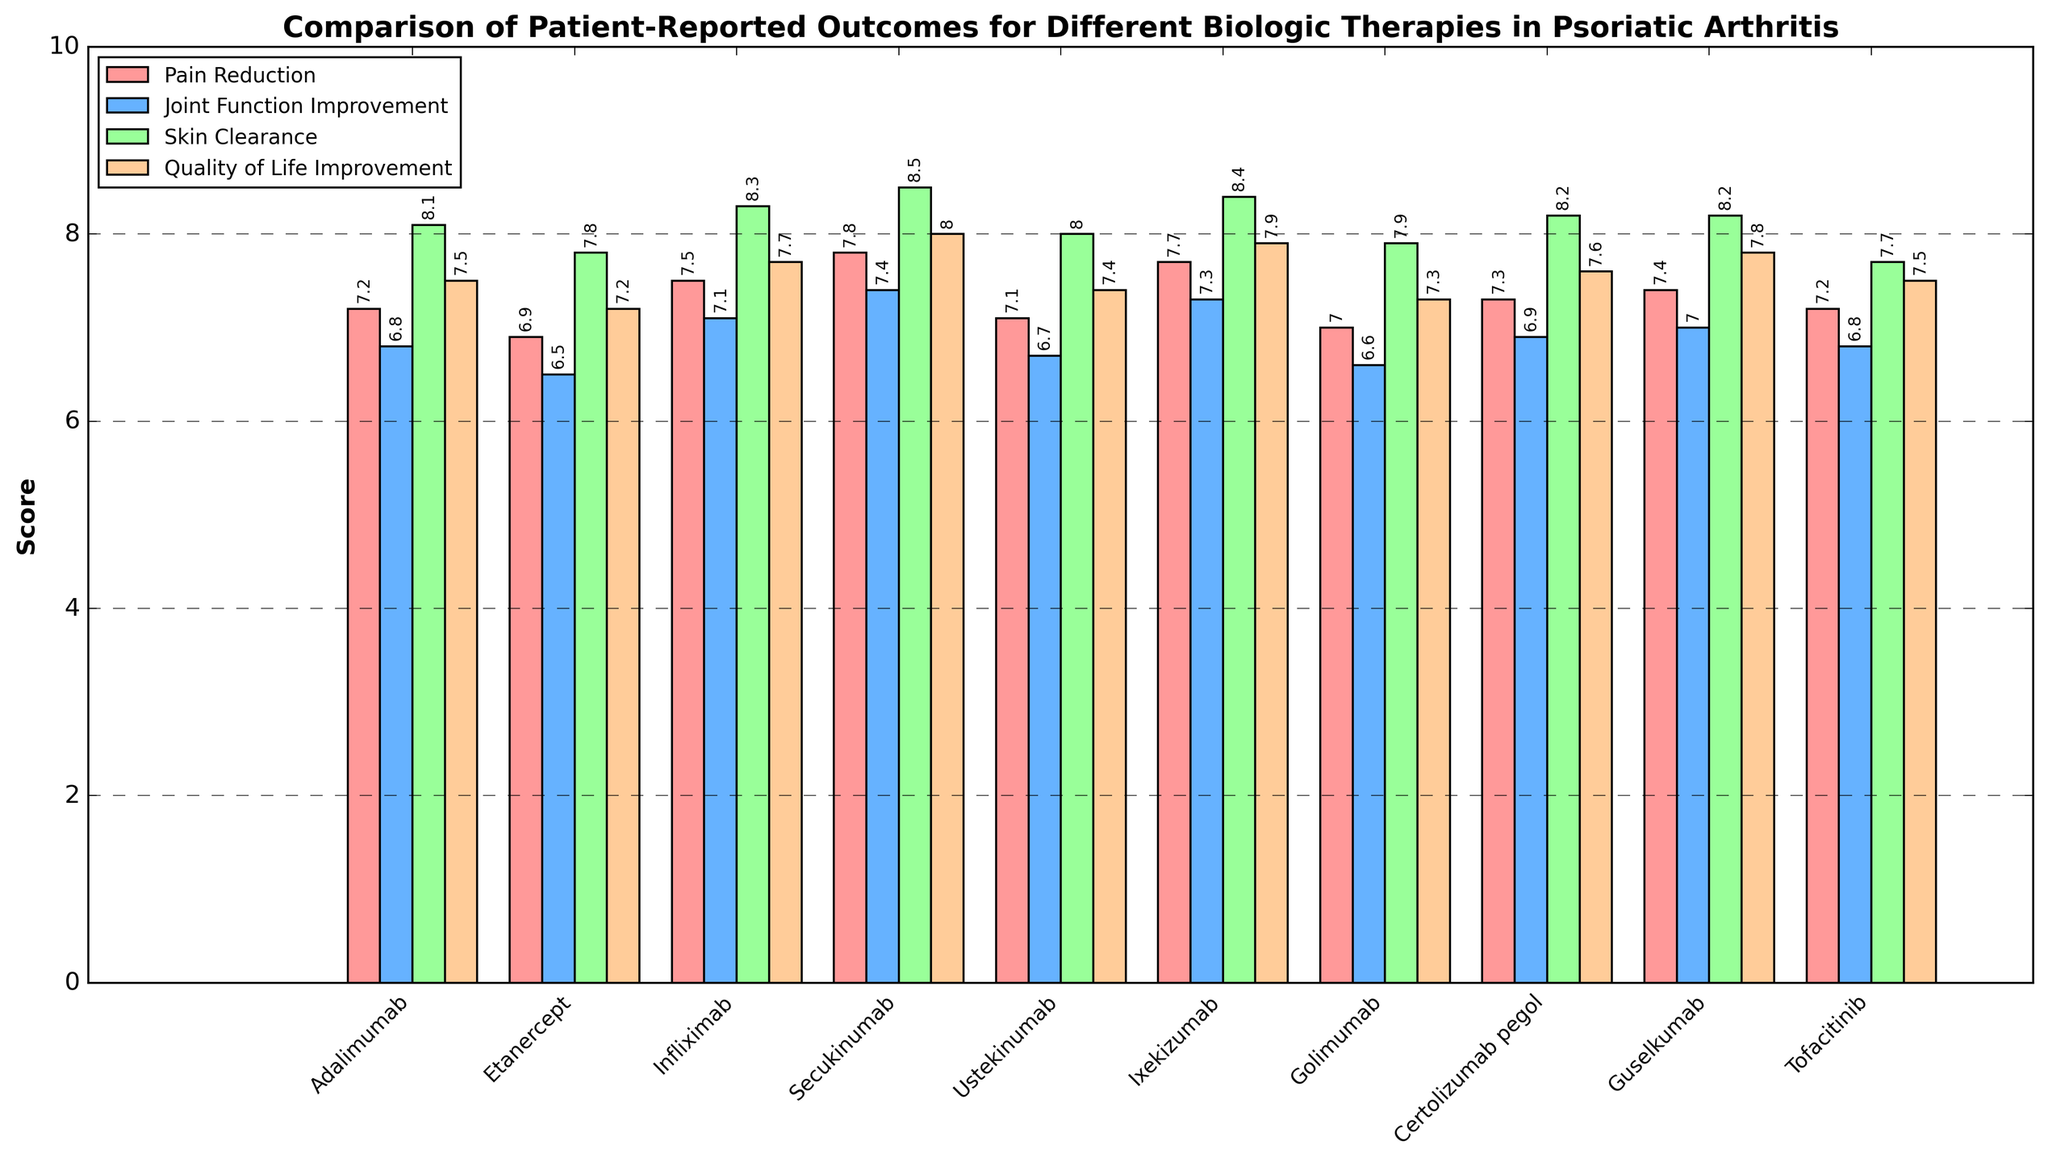Which biologic therapy has the highest pain reduction score? First, identify the scores for pain reduction. Secukinumab has the highest score of 7.8.
Answer: Secukinumab How does the joint function improvement of Ixekizumab compare to that of Golimumab? Compare the joint function improvement scores: Ixekizumab has 7.3 and Golimumab has 6.6. Ixekizumab's score is higher.
Answer: Ixekizumab is higher Which treatment shows the greatest improvement in quality of life? Check the quality of life improvement scores: Secukinumab has the highest score of 8.0.
Answer: Secukinumab On average, what is the pain reduction score across all treatments? Sum all pain reduction scores and divide by the number of treatments (7.2 + 6.9 + 7.5 + 7.8 + 7.1 + 7.7 + 7.0 + 7.3 + 7.4 + 7.2)/10. The average is 7.31.
Answer: 7.31 Which therapy has the lowest score in skin clearance? Identify the lowest score in skin clearance: Tofacitinib has the lowest score of 7.7.
Answer: Tofacitinib Is the pain reduction of Adalimumab greater than that of Etanercept and by how much? Compare the pain reduction scores: Adalimumab has 7.2 and Etanercept has 6.9, so Adalimumab is greater by 0.3.
Answer: Yes, by 0.3 Does any treatment have the same score for joint function improvement and quality of life improvement? Compare the scores for joint function improvement and quality of life improvement for each treatment. No treatment has the exact same scores for both.
Answer: No Which two therapies have the closest scores for skin clearance, and what are those scores? Compare the skin clearance scores: Guselkumab (8.2) and Certolizumab pegol (8.2) have the closest scores, being equal.
Answer: Guselkumab and Certolizumab pegol; 8.2 What is the difference between the highest and lowest joint function improvement scores? Identify the highest and lowest scores for joint function improvement: Secukinumab (7.4) and Golimumab (6.6), the difference is 7.4 - 6.6 = 0.8.
Answer: 0.8 Which therapy has the highest combined score for all four outcomes? Sum the scores for all four outcomes for each therapy and identify the highest: Secukinumab has the highest combined score (7.8 + 7.4 + 8.5 + 8.0) = 31.7.
Answer: Secukinumab 